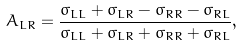<formula> <loc_0><loc_0><loc_500><loc_500>A _ { L R } = \frac { \sigma _ { L L } + \sigma _ { L R } - \sigma _ { R R } - \sigma _ { R L } } { \sigma _ { L L } + \sigma _ { L R } + \sigma _ { R R } + \sigma _ { R L } } ,</formula> 